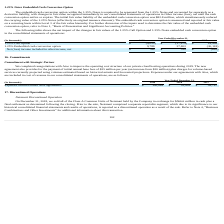According to Allscripts Healthcare Solutions's financial document, What is the 1.25% Embedded cash conversion option value in 2019? According to the financial document, 9,789 (in thousands). The relevant text states: "1.25% Embedded cash conversion option 9,789 37,803 (30,118)..." Also, What was the initial fair value liability of the embedded cash conversion option? According to the financial document, $82.8 million. The relevant text states: "ability of the embedded cash conversion option was $82.8 million, which simultaneously reduced the carrying value of the 1.25% Notes (effectively an original issuan..." Also, What was the value of 1.25% call option in 2019? According to the financial document, $ (9,020) (in thousands). The relevant text states: "1.25% Call Option $ (9,020) $ (37,474) $ 29,498..." Also, can you calculate: What is the change in the value of 1.25% call option from 2018 to 2019? Based on the calculation: -9,020 - (-37,474), the result is 28454 (in thousands). This is based on the information: "1.25% Call Option $ (9,020) $ (37,474) $ 29,498 1.25% Call Option $ (9,020) $ (37,474) $ 29,498..." The key data points involved are: 37,474, 9,020. Also, can you calculate: What is the average 1.25% Embedded cash conversion option between 2017-2019? To answer this question, I need to perform calculations using the financial data. The calculation is: (9,789 + 37,803 - 30,118) / 3, which equals 5824.67 (in thousands). This is based on the information: "1.25% Embedded cash conversion option 9,789 37,803 (30,118) 1.25% Embedded cash conversion option 9,789 37,803 (30,118) 25% Embedded cash conversion option 9,789 37,803 (30,118)..." The key data points involved are: 30,118, 37,803, 9,789. Also, can you calculate: What is the change in the Net (loss) income included in other income, net from 2018 to 2019? Based on the calculation: 769 - 329, the result is 440 (in thousands). This is based on the information: "Net (loss) income included in other income, net $ 769 $ 329 $ (620) oss) income included in other income, net $ 769 $ 329 $ (620)..." The key data points involved are: 329, 769. 